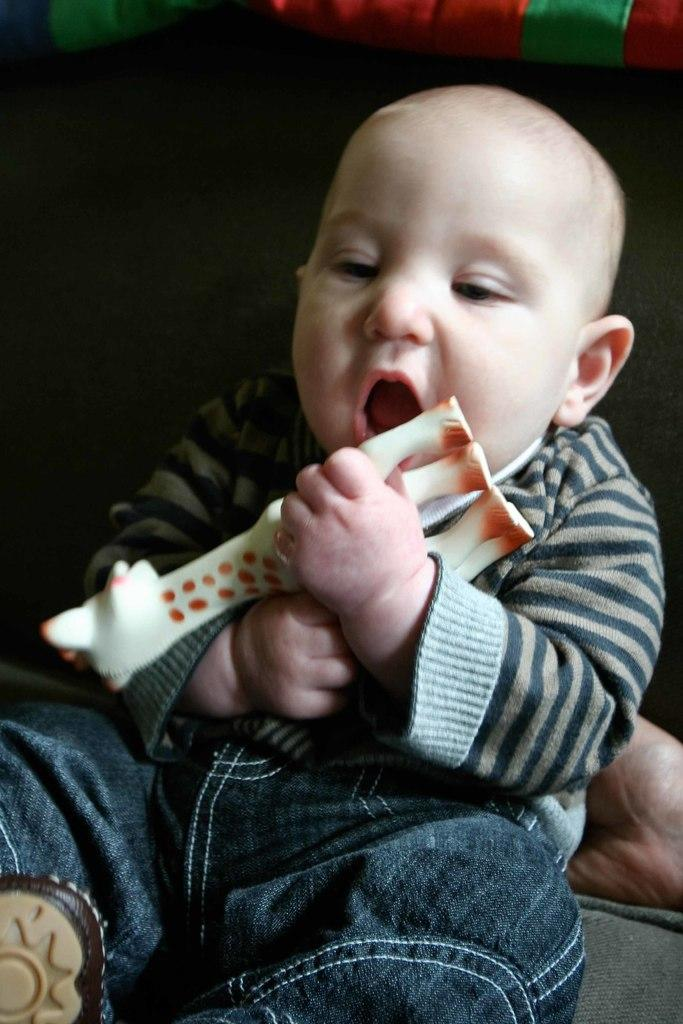What is the main subject of the image? There is a baby in the image. What is the baby holding in the image? The baby is holding a toy. How is the baby holding the toy? The baby's hands are holding the toy. Can you describe any other elements in the image? There appears to be a hand of a person behind the baby. What color is the grape that the baby is eating in the image? There is no grape present in the image; the baby is holding a toy. What type of truck can be seen in the background of the image? There is no truck visible in the image; it only features a baby holding a toy and a hand behind the baby. 